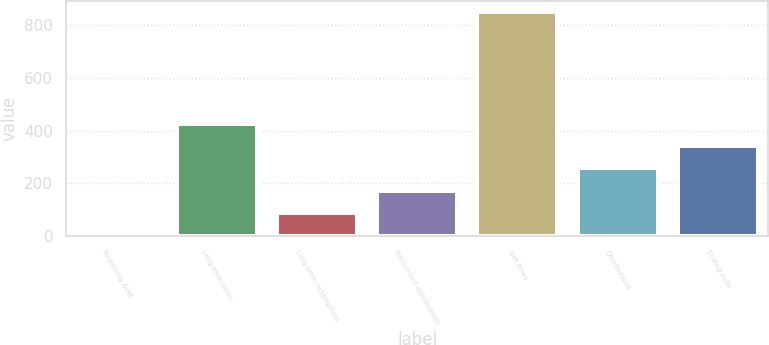<chart> <loc_0><loc_0><loc_500><loc_500><bar_chart><fcel>Beginning AUM<fcel>Long-term sales<fcel>Long-term redemptions<fcel>Reinvested distributions<fcel>Net flows<fcel>Distributions<fcel>Ending AUM<nl><fcel>3<fcel>425<fcel>87.4<fcel>171.8<fcel>847<fcel>256.2<fcel>340.6<nl></chart> 